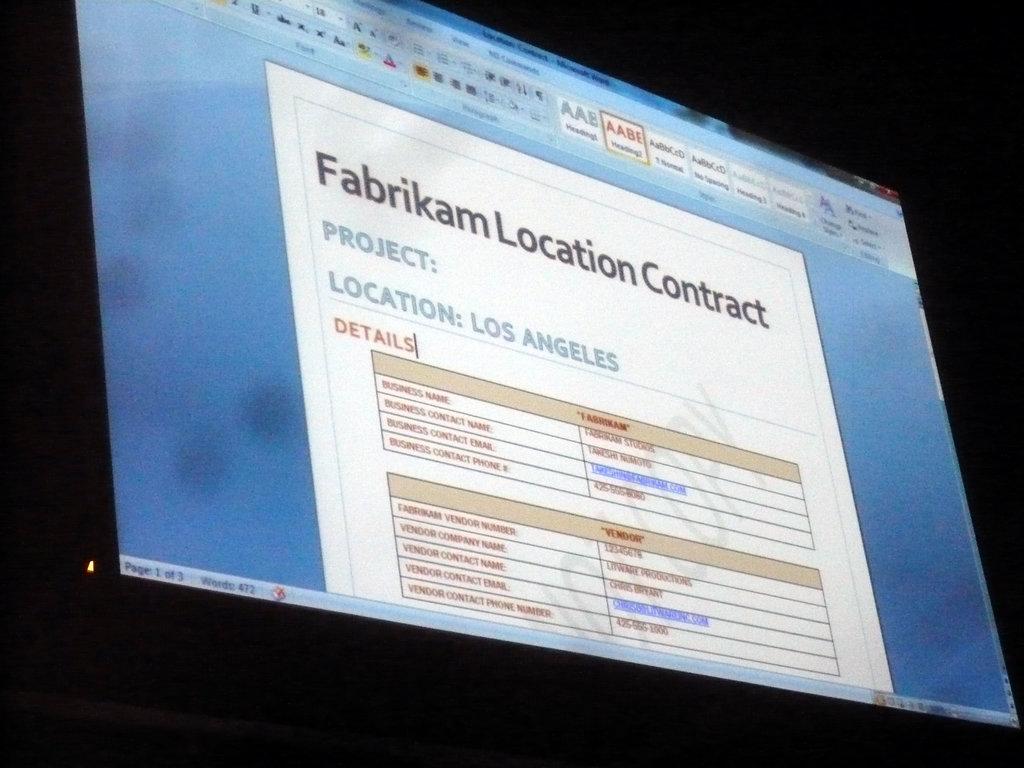Where is the project located?
Keep it short and to the point. Los angeles. What is the title of the project?
Your answer should be compact. Fabrikam location contract. 